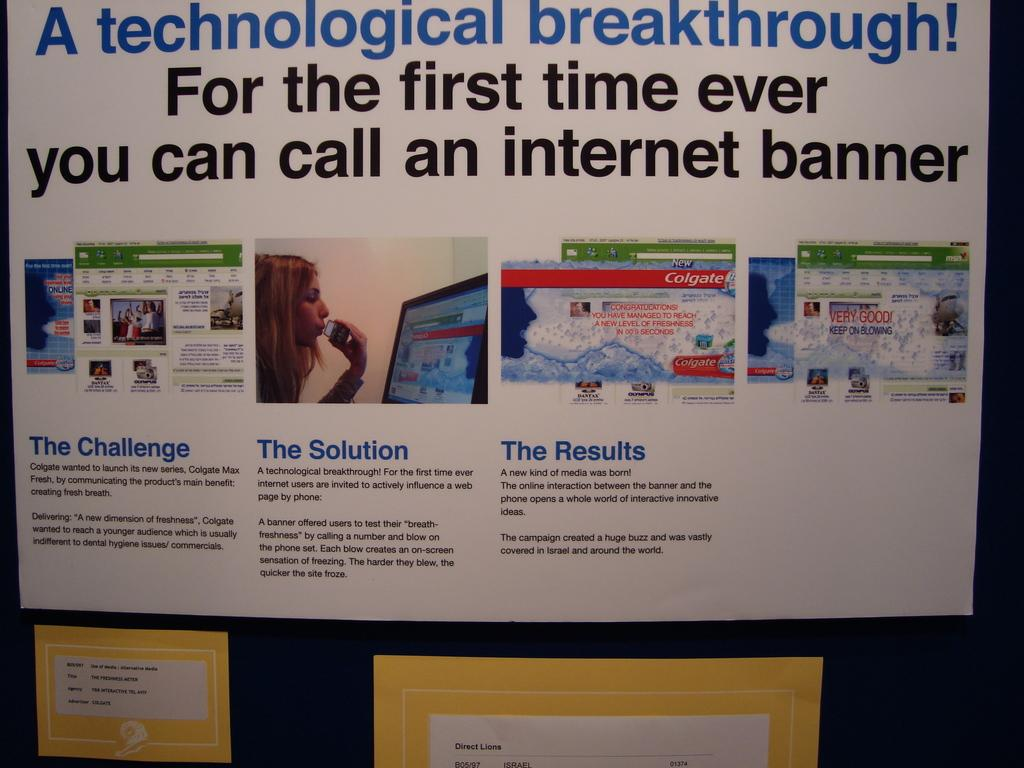<image>
Provide a brief description of the given image. Sign on the wall with blue words that say "A technological breakthrough!". 